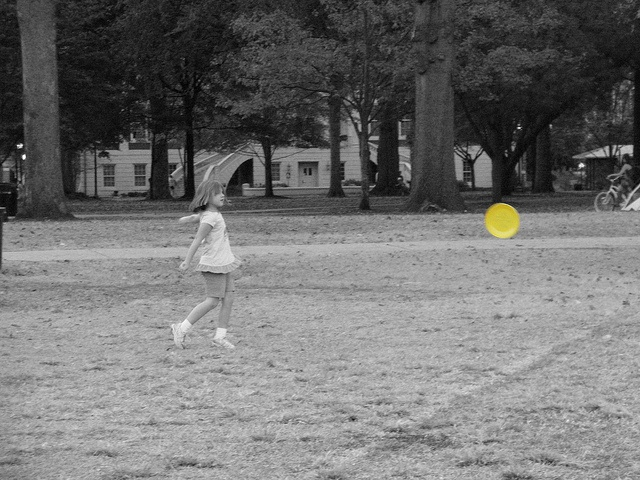Describe the objects in this image and their specific colors. I can see people in black, darkgray, lightgray, and gray tones, frisbee in black, khaki, and gold tones, people in gray and black tones, bicycle in gray and black tones, and people in black and gray tones in this image. 